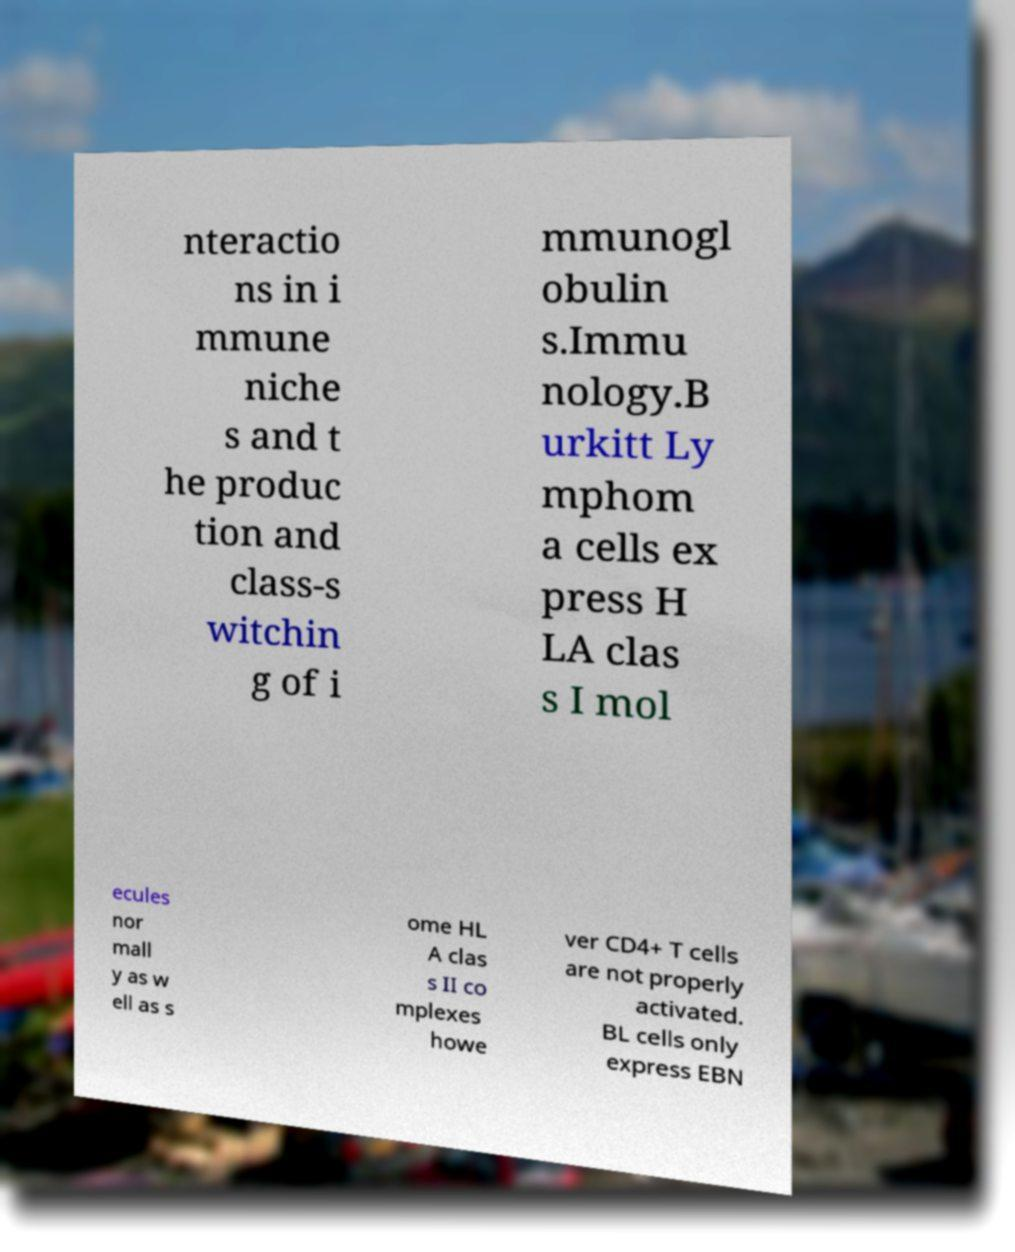What messages or text are displayed in this image? I need them in a readable, typed format. nteractio ns in i mmune niche s and t he produc tion and class-s witchin g of i mmunogl obulin s.Immu nology.B urkitt Ly mphom a cells ex press H LA clas s I mol ecules nor mall y as w ell as s ome HL A clas s II co mplexes howe ver CD4+ T cells are not properly activated. BL cells only express EBN 